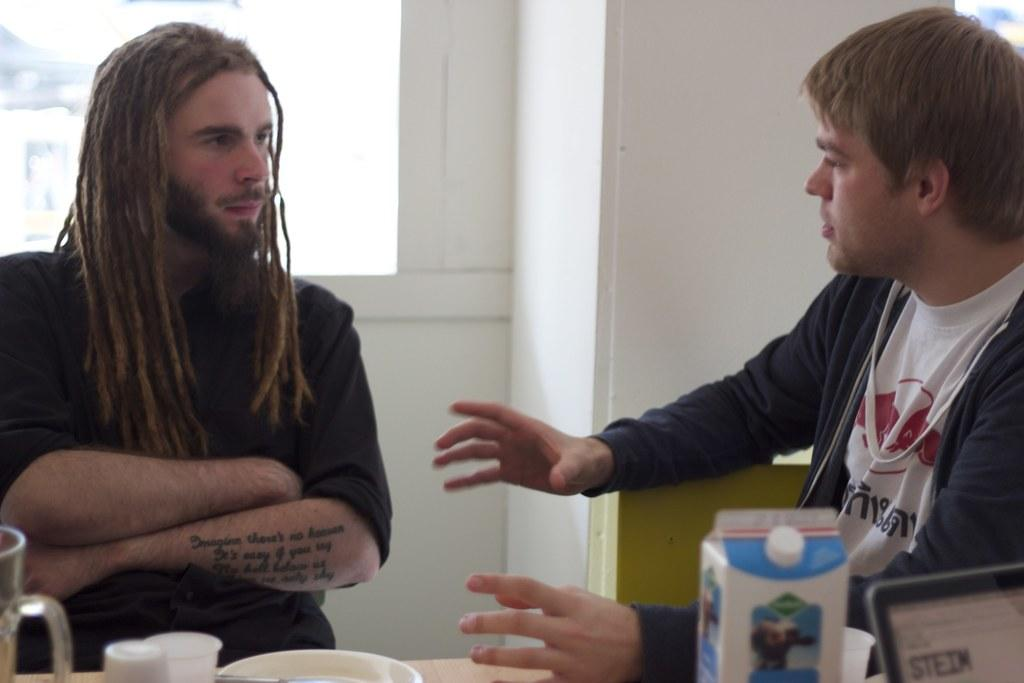How many people are sitting in the image? There are two persons sitting on chairs in the image. What objects are on the table? There are glasses, a plate, a sachet, and a device on the table. What can be seen in the background of the image? There is a wall and a window in the background of the image. What type of organization is depicted in the image? There is no organization depicted in the image; it features two people sitting on chairs with objects on a table and a wall and window in the background. 